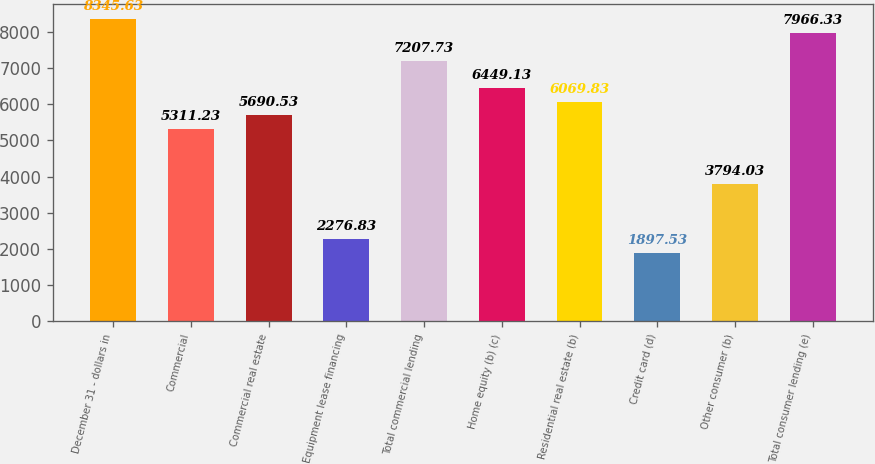Convert chart to OTSL. <chart><loc_0><loc_0><loc_500><loc_500><bar_chart><fcel>December 31 - dollars in<fcel>Commercial<fcel>Commercial real estate<fcel>Equipment lease financing<fcel>Total commercial lending<fcel>Home equity (b) (c)<fcel>Residential real estate (b)<fcel>Credit card (d)<fcel>Other consumer (b)<fcel>Total consumer lending (e)<nl><fcel>8345.63<fcel>5311.23<fcel>5690.53<fcel>2276.83<fcel>7207.73<fcel>6449.13<fcel>6069.83<fcel>1897.53<fcel>3794.03<fcel>7966.33<nl></chart> 